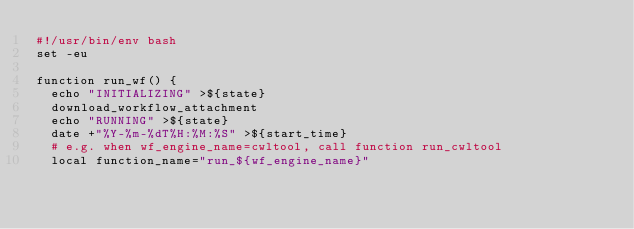<code> <loc_0><loc_0><loc_500><loc_500><_Bash_>#!/usr/bin/env bash
set -eu

function run_wf() {
  echo "INITIALIZING" >${state}
  download_workflow_attachment
  echo "RUNNING" >${state}
  date +"%Y-%m-%dT%H:%M:%S" >${start_time}
  # e.g. when wf_engine_name=cwltool, call function run_cwltool
  local function_name="run_${wf_engine_name}"</code> 